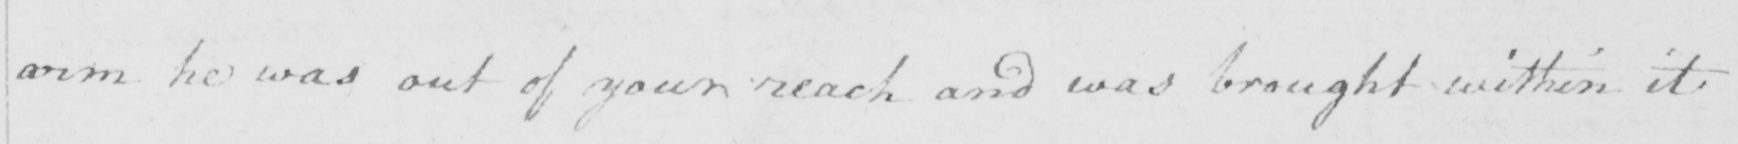Can you tell me what this handwritten text says? arm he was out of your reach and was bought within it 